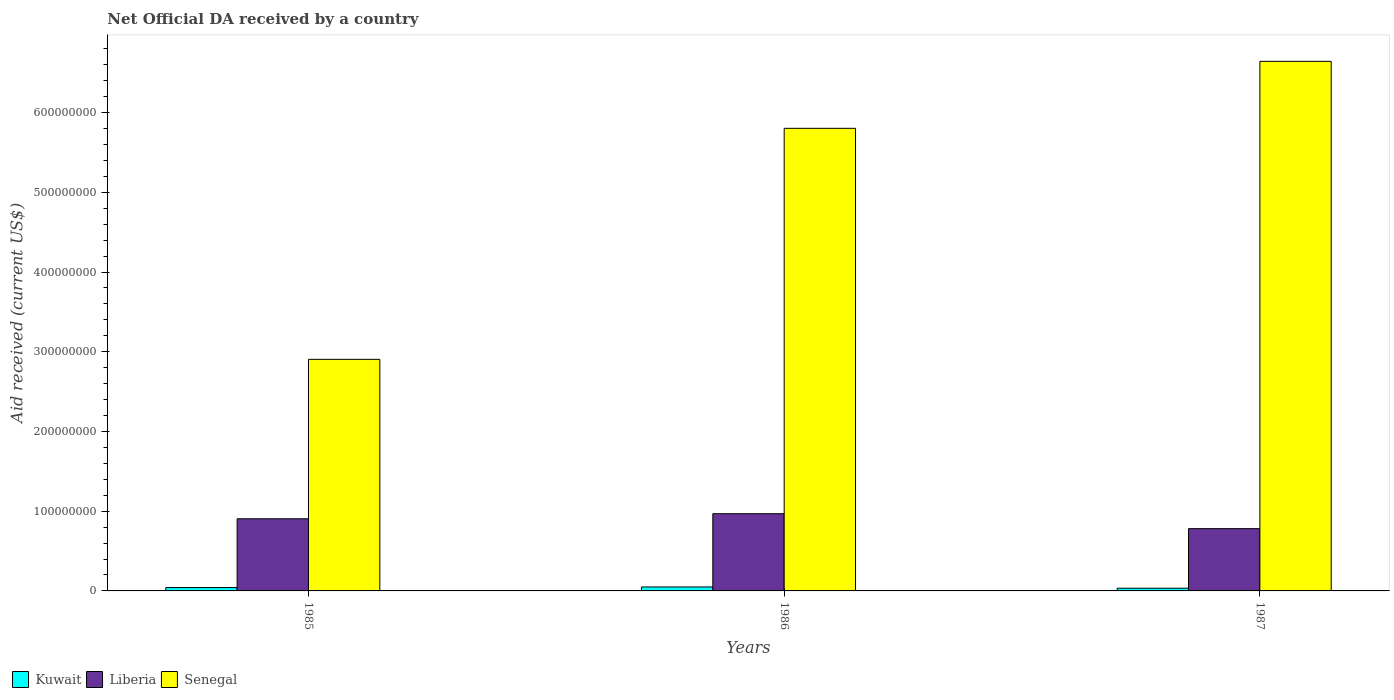How many different coloured bars are there?
Keep it short and to the point. 3. Are the number of bars on each tick of the X-axis equal?
Provide a short and direct response. Yes. How many bars are there on the 2nd tick from the left?
Ensure brevity in your answer.  3. In how many cases, is the number of bars for a given year not equal to the number of legend labels?
Give a very brief answer. 0. What is the net official development assistance aid received in Kuwait in 1987?
Give a very brief answer. 3.39e+06. Across all years, what is the maximum net official development assistance aid received in Kuwait?
Keep it short and to the point. 4.96e+06. Across all years, what is the minimum net official development assistance aid received in Senegal?
Your answer should be compact. 2.90e+08. In which year was the net official development assistance aid received in Liberia maximum?
Your answer should be compact. 1986. In which year was the net official development assistance aid received in Senegal minimum?
Ensure brevity in your answer.  1985. What is the total net official development assistance aid received in Liberia in the graph?
Your answer should be very brief. 2.65e+08. What is the difference between the net official development assistance aid received in Liberia in 1986 and that in 1987?
Your answer should be very brief. 1.87e+07. What is the difference between the net official development assistance aid received in Kuwait in 1986 and the net official development assistance aid received in Liberia in 1985?
Provide a succinct answer. -8.55e+07. What is the average net official development assistance aid received in Liberia per year?
Provide a short and direct response. 8.85e+07. In the year 1986, what is the difference between the net official development assistance aid received in Liberia and net official development assistance aid received in Senegal?
Keep it short and to the point. -4.83e+08. What is the ratio of the net official development assistance aid received in Liberia in 1986 to that in 1987?
Your response must be concise. 1.24. What is the difference between the highest and the second highest net official development assistance aid received in Liberia?
Provide a short and direct response. 6.35e+06. What is the difference between the highest and the lowest net official development assistance aid received in Senegal?
Keep it short and to the point. 3.74e+08. In how many years, is the net official development assistance aid received in Kuwait greater than the average net official development assistance aid received in Kuwait taken over all years?
Provide a succinct answer. 2. Is the sum of the net official development assistance aid received in Kuwait in 1986 and 1987 greater than the maximum net official development assistance aid received in Liberia across all years?
Provide a succinct answer. No. What does the 2nd bar from the left in 1987 represents?
Ensure brevity in your answer.  Liberia. What does the 1st bar from the right in 1985 represents?
Offer a very short reply. Senegal. Is it the case that in every year, the sum of the net official development assistance aid received in Senegal and net official development assistance aid received in Kuwait is greater than the net official development assistance aid received in Liberia?
Ensure brevity in your answer.  Yes. How many bars are there?
Offer a terse response. 9. Are all the bars in the graph horizontal?
Your answer should be very brief. No. Does the graph contain any zero values?
Your answer should be compact. No. What is the title of the graph?
Your answer should be compact. Net Official DA received by a country. Does "Luxembourg" appear as one of the legend labels in the graph?
Your answer should be very brief. No. What is the label or title of the Y-axis?
Your answer should be compact. Aid received (current US$). What is the Aid received (current US$) of Kuwait in 1985?
Your answer should be compact. 4.21e+06. What is the Aid received (current US$) in Liberia in 1985?
Keep it short and to the point. 9.05e+07. What is the Aid received (current US$) in Senegal in 1985?
Keep it short and to the point. 2.90e+08. What is the Aid received (current US$) of Kuwait in 1986?
Offer a terse response. 4.96e+06. What is the Aid received (current US$) of Liberia in 1986?
Make the answer very short. 9.68e+07. What is the Aid received (current US$) of Senegal in 1986?
Your response must be concise. 5.80e+08. What is the Aid received (current US$) of Kuwait in 1987?
Ensure brevity in your answer.  3.39e+06. What is the Aid received (current US$) of Liberia in 1987?
Your answer should be very brief. 7.81e+07. What is the Aid received (current US$) of Senegal in 1987?
Offer a terse response. 6.64e+08. Across all years, what is the maximum Aid received (current US$) of Kuwait?
Ensure brevity in your answer.  4.96e+06. Across all years, what is the maximum Aid received (current US$) of Liberia?
Keep it short and to the point. 9.68e+07. Across all years, what is the maximum Aid received (current US$) in Senegal?
Ensure brevity in your answer.  6.64e+08. Across all years, what is the minimum Aid received (current US$) of Kuwait?
Give a very brief answer. 3.39e+06. Across all years, what is the minimum Aid received (current US$) in Liberia?
Your answer should be compact. 7.81e+07. Across all years, what is the minimum Aid received (current US$) of Senegal?
Offer a very short reply. 2.90e+08. What is the total Aid received (current US$) in Kuwait in the graph?
Offer a terse response. 1.26e+07. What is the total Aid received (current US$) in Liberia in the graph?
Offer a very short reply. 2.65e+08. What is the total Aid received (current US$) in Senegal in the graph?
Your answer should be very brief. 1.53e+09. What is the difference between the Aid received (current US$) of Kuwait in 1985 and that in 1986?
Give a very brief answer. -7.50e+05. What is the difference between the Aid received (current US$) in Liberia in 1985 and that in 1986?
Provide a short and direct response. -6.35e+06. What is the difference between the Aid received (current US$) in Senegal in 1985 and that in 1986?
Give a very brief answer. -2.90e+08. What is the difference between the Aid received (current US$) of Kuwait in 1985 and that in 1987?
Your answer should be very brief. 8.20e+05. What is the difference between the Aid received (current US$) of Liberia in 1985 and that in 1987?
Offer a terse response. 1.24e+07. What is the difference between the Aid received (current US$) in Senegal in 1985 and that in 1987?
Provide a short and direct response. -3.74e+08. What is the difference between the Aid received (current US$) in Kuwait in 1986 and that in 1987?
Keep it short and to the point. 1.57e+06. What is the difference between the Aid received (current US$) in Liberia in 1986 and that in 1987?
Give a very brief answer. 1.87e+07. What is the difference between the Aid received (current US$) of Senegal in 1986 and that in 1987?
Keep it short and to the point. -8.40e+07. What is the difference between the Aid received (current US$) in Kuwait in 1985 and the Aid received (current US$) in Liberia in 1986?
Keep it short and to the point. -9.26e+07. What is the difference between the Aid received (current US$) in Kuwait in 1985 and the Aid received (current US$) in Senegal in 1986?
Offer a very short reply. -5.76e+08. What is the difference between the Aid received (current US$) of Liberia in 1985 and the Aid received (current US$) of Senegal in 1986?
Ensure brevity in your answer.  -4.90e+08. What is the difference between the Aid received (current US$) in Kuwait in 1985 and the Aid received (current US$) in Liberia in 1987?
Your answer should be very brief. -7.39e+07. What is the difference between the Aid received (current US$) of Kuwait in 1985 and the Aid received (current US$) of Senegal in 1987?
Your answer should be very brief. -6.60e+08. What is the difference between the Aid received (current US$) of Liberia in 1985 and the Aid received (current US$) of Senegal in 1987?
Your answer should be compact. -5.74e+08. What is the difference between the Aid received (current US$) in Kuwait in 1986 and the Aid received (current US$) in Liberia in 1987?
Give a very brief answer. -7.31e+07. What is the difference between the Aid received (current US$) of Kuwait in 1986 and the Aid received (current US$) of Senegal in 1987?
Make the answer very short. -6.59e+08. What is the difference between the Aid received (current US$) of Liberia in 1986 and the Aid received (current US$) of Senegal in 1987?
Your answer should be very brief. -5.67e+08. What is the average Aid received (current US$) of Kuwait per year?
Give a very brief answer. 4.19e+06. What is the average Aid received (current US$) in Liberia per year?
Your answer should be compact. 8.85e+07. What is the average Aid received (current US$) of Senegal per year?
Offer a terse response. 5.12e+08. In the year 1985, what is the difference between the Aid received (current US$) of Kuwait and Aid received (current US$) of Liberia?
Offer a terse response. -8.63e+07. In the year 1985, what is the difference between the Aid received (current US$) in Kuwait and Aid received (current US$) in Senegal?
Offer a terse response. -2.86e+08. In the year 1985, what is the difference between the Aid received (current US$) in Liberia and Aid received (current US$) in Senegal?
Give a very brief answer. -2.00e+08. In the year 1986, what is the difference between the Aid received (current US$) in Kuwait and Aid received (current US$) in Liberia?
Give a very brief answer. -9.19e+07. In the year 1986, what is the difference between the Aid received (current US$) in Kuwait and Aid received (current US$) in Senegal?
Provide a succinct answer. -5.75e+08. In the year 1986, what is the difference between the Aid received (current US$) in Liberia and Aid received (current US$) in Senegal?
Your response must be concise. -4.83e+08. In the year 1987, what is the difference between the Aid received (current US$) of Kuwait and Aid received (current US$) of Liberia?
Offer a terse response. -7.47e+07. In the year 1987, what is the difference between the Aid received (current US$) in Kuwait and Aid received (current US$) in Senegal?
Provide a short and direct response. -6.61e+08. In the year 1987, what is the difference between the Aid received (current US$) in Liberia and Aid received (current US$) in Senegal?
Your answer should be compact. -5.86e+08. What is the ratio of the Aid received (current US$) in Kuwait in 1985 to that in 1986?
Make the answer very short. 0.85. What is the ratio of the Aid received (current US$) in Liberia in 1985 to that in 1986?
Give a very brief answer. 0.93. What is the ratio of the Aid received (current US$) of Senegal in 1985 to that in 1986?
Provide a succinct answer. 0.5. What is the ratio of the Aid received (current US$) in Kuwait in 1985 to that in 1987?
Give a very brief answer. 1.24. What is the ratio of the Aid received (current US$) in Liberia in 1985 to that in 1987?
Your answer should be compact. 1.16. What is the ratio of the Aid received (current US$) of Senegal in 1985 to that in 1987?
Keep it short and to the point. 0.44. What is the ratio of the Aid received (current US$) of Kuwait in 1986 to that in 1987?
Your response must be concise. 1.46. What is the ratio of the Aid received (current US$) in Liberia in 1986 to that in 1987?
Offer a terse response. 1.24. What is the ratio of the Aid received (current US$) of Senegal in 1986 to that in 1987?
Keep it short and to the point. 0.87. What is the difference between the highest and the second highest Aid received (current US$) of Kuwait?
Provide a succinct answer. 7.50e+05. What is the difference between the highest and the second highest Aid received (current US$) in Liberia?
Offer a terse response. 6.35e+06. What is the difference between the highest and the second highest Aid received (current US$) in Senegal?
Make the answer very short. 8.40e+07. What is the difference between the highest and the lowest Aid received (current US$) of Kuwait?
Keep it short and to the point. 1.57e+06. What is the difference between the highest and the lowest Aid received (current US$) in Liberia?
Keep it short and to the point. 1.87e+07. What is the difference between the highest and the lowest Aid received (current US$) of Senegal?
Your answer should be very brief. 3.74e+08. 